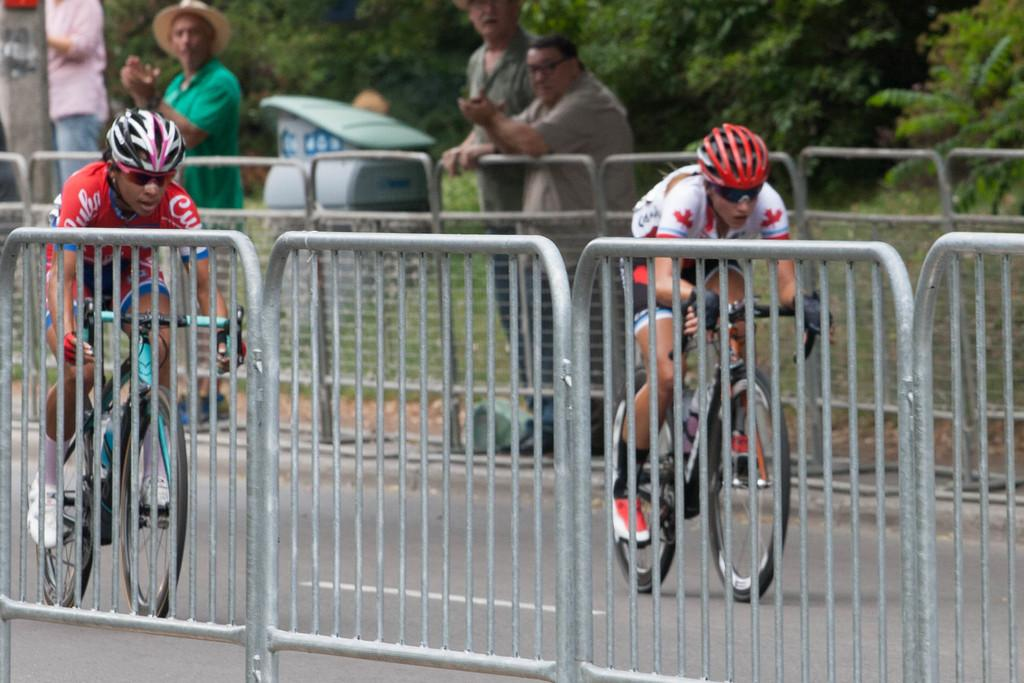How many men are in the image? There are two men in the image. What protective gear are the men wearing? The men are wearing helmets and goggles. What activity are the men engaged in? The men are riding bicycles. Where are the bicycles located? The bicycles are on a road. How many people are standing in the image? There are four people standing in the image. What type of barrier can be seen in the image? There are fences in the image. What type of vegetation is present in the image? There is grass in the image. What objects can be seen in the image? There are some objects in the image. What can be seen in the background of the image? There are trees in the background of the image. How many frogs are hopping on the sand in the image? There are no frogs or sand present in the image. What type of plantation can be seen in the background of the image? There is no plantation visible in the image; only trees can be seen in the background. 